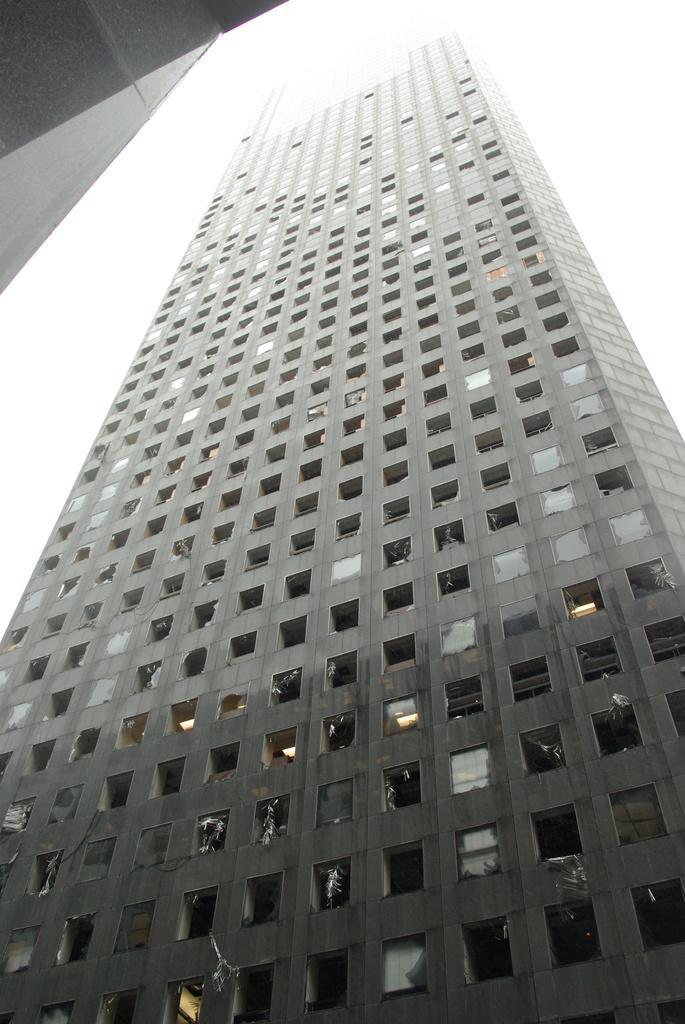Please provide a concise description of this image. This picture shows a tall building. We see another building on the side and we see a cloudy sky. 